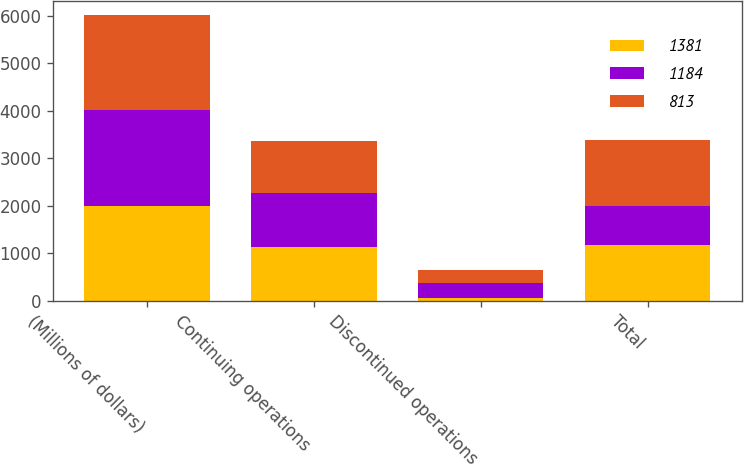Convert chart. <chart><loc_0><loc_0><loc_500><loc_500><stacked_bar_chart><ecel><fcel>(Millions of dollars)<fcel>Continuing operations<fcel>Discontinued operations<fcel>Total<nl><fcel>1381<fcel>2005<fcel>1131<fcel>53<fcel>1184<nl><fcel>1184<fcel>2004<fcel>1128<fcel>315<fcel>813<nl><fcel>813<fcel>2003<fcel>1106<fcel>275<fcel>1381<nl></chart> 